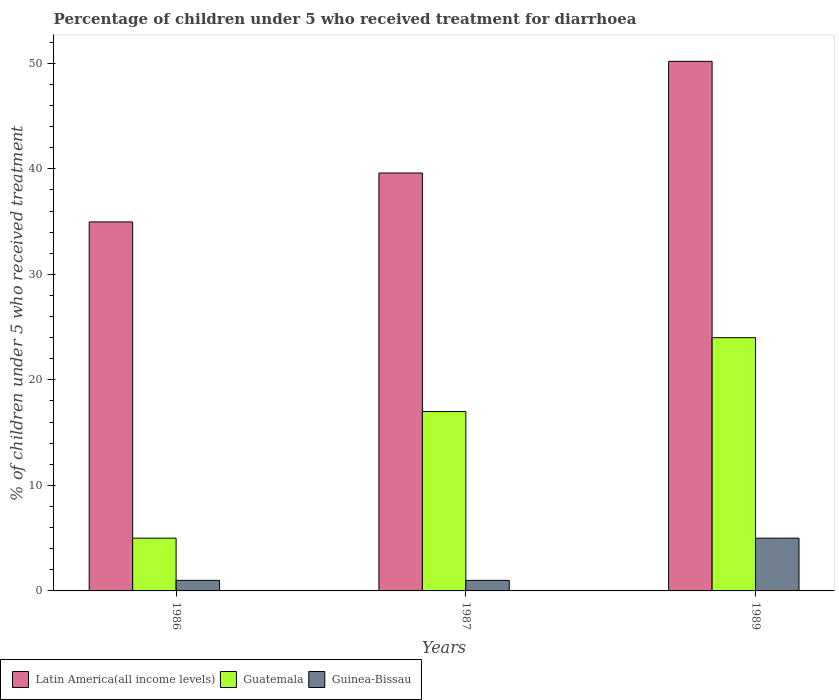How many different coloured bars are there?
Offer a very short reply. 3. Are the number of bars per tick equal to the number of legend labels?
Provide a short and direct response. Yes. Are the number of bars on each tick of the X-axis equal?
Your response must be concise. Yes. How many bars are there on the 1st tick from the left?
Ensure brevity in your answer.  3. How many bars are there on the 1st tick from the right?
Keep it short and to the point. 3. In how many cases, is the number of bars for a given year not equal to the number of legend labels?
Keep it short and to the point. 0. What is the percentage of children who received treatment for diarrhoea  in Latin America(all income levels) in 1987?
Keep it short and to the point. 39.6. Across all years, what is the maximum percentage of children who received treatment for diarrhoea  in Latin America(all income levels)?
Your answer should be very brief. 50.19. Across all years, what is the minimum percentage of children who received treatment for diarrhoea  in Latin America(all income levels)?
Your answer should be compact. 34.97. What is the total percentage of children who received treatment for diarrhoea  in Latin America(all income levels) in the graph?
Ensure brevity in your answer.  124.76. What is the difference between the percentage of children who received treatment for diarrhoea  in Latin America(all income levels) in 1986 and that in 1987?
Provide a short and direct response. -4.64. What is the difference between the percentage of children who received treatment for diarrhoea  in Latin America(all income levels) in 1986 and the percentage of children who received treatment for diarrhoea  in Guatemala in 1987?
Keep it short and to the point. 17.97. What is the average percentage of children who received treatment for diarrhoea  in Guinea-Bissau per year?
Your answer should be compact. 2.33. What is the ratio of the percentage of children who received treatment for diarrhoea  in Latin America(all income levels) in 1986 to that in 1989?
Make the answer very short. 0.7. What is the difference between the highest and the second highest percentage of children who received treatment for diarrhoea  in Guinea-Bissau?
Keep it short and to the point. 4. What is the difference between the highest and the lowest percentage of children who received treatment for diarrhoea  in Latin America(all income levels)?
Provide a succinct answer. 15.22. In how many years, is the percentage of children who received treatment for diarrhoea  in Latin America(all income levels) greater than the average percentage of children who received treatment for diarrhoea  in Latin America(all income levels) taken over all years?
Ensure brevity in your answer.  1. What does the 3rd bar from the left in 1989 represents?
Offer a very short reply. Guinea-Bissau. What does the 1st bar from the right in 1987 represents?
Give a very brief answer. Guinea-Bissau. Is it the case that in every year, the sum of the percentage of children who received treatment for diarrhoea  in Guatemala and percentage of children who received treatment for diarrhoea  in Latin America(all income levels) is greater than the percentage of children who received treatment for diarrhoea  in Guinea-Bissau?
Your answer should be very brief. Yes. How many bars are there?
Ensure brevity in your answer.  9. How many years are there in the graph?
Your answer should be very brief. 3. What is the difference between two consecutive major ticks on the Y-axis?
Offer a very short reply. 10. How many legend labels are there?
Make the answer very short. 3. What is the title of the graph?
Ensure brevity in your answer.  Percentage of children under 5 who received treatment for diarrhoea. Does "Sao Tome and Principe" appear as one of the legend labels in the graph?
Provide a succinct answer. No. What is the label or title of the X-axis?
Offer a terse response. Years. What is the label or title of the Y-axis?
Your answer should be compact. % of children under 5 who received treatment. What is the % of children under 5 who received treatment in Latin America(all income levels) in 1986?
Give a very brief answer. 34.97. What is the % of children under 5 who received treatment in Latin America(all income levels) in 1987?
Provide a short and direct response. 39.6. What is the % of children under 5 who received treatment in Guatemala in 1987?
Provide a succinct answer. 17. What is the % of children under 5 who received treatment in Latin America(all income levels) in 1989?
Provide a succinct answer. 50.19. Across all years, what is the maximum % of children under 5 who received treatment of Latin America(all income levels)?
Offer a terse response. 50.19. Across all years, what is the minimum % of children under 5 who received treatment of Latin America(all income levels)?
Offer a very short reply. 34.97. Across all years, what is the minimum % of children under 5 who received treatment in Guatemala?
Your answer should be very brief. 5. Across all years, what is the minimum % of children under 5 who received treatment of Guinea-Bissau?
Make the answer very short. 1. What is the total % of children under 5 who received treatment in Latin America(all income levels) in the graph?
Give a very brief answer. 124.76. What is the total % of children under 5 who received treatment of Guinea-Bissau in the graph?
Provide a short and direct response. 7. What is the difference between the % of children under 5 who received treatment of Latin America(all income levels) in 1986 and that in 1987?
Provide a succinct answer. -4.64. What is the difference between the % of children under 5 who received treatment of Guatemala in 1986 and that in 1987?
Make the answer very short. -12. What is the difference between the % of children under 5 who received treatment in Guinea-Bissau in 1986 and that in 1987?
Your answer should be compact. 0. What is the difference between the % of children under 5 who received treatment of Latin America(all income levels) in 1986 and that in 1989?
Offer a terse response. -15.22. What is the difference between the % of children under 5 who received treatment in Guinea-Bissau in 1986 and that in 1989?
Offer a very short reply. -4. What is the difference between the % of children under 5 who received treatment in Latin America(all income levels) in 1987 and that in 1989?
Provide a succinct answer. -10.58. What is the difference between the % of children under 5 who received treatment in Guinea-Bissau in 1987 and that in 1989?
Ensure brevity in your answer.  -4. What is the difference between the % of children under 5 who received treatment in Latin America(all income levels) in 1986 and the % of children under 5 who received treatment in Guatemala in 1987?
Provide a succinct answer. 17.97. What is the difference between the % of children under 5 who received treatment in Latin America(all income levels) in 1986 and the % of children under 5 who received treatment in Guinea-Bissau in 1987?
Offer a very short reply. 33.97. What is the difference between the % of children under 5 who received treatment of Latin America(all income levels) in 1986 and the % of children under 5 who received treatment of Guatemala in 1989?
Your answer should be compact. 10.97. What is the difference between the % of children under 5 who received treatment in Latin America(all income levels) in 1986 and the % of children under 5 who received treatment in Guinea-Bissau in 1989?
Offer a very short reply. 29.97. What is the difference between the % of children under 5 who received treatment in Guatemala in 1986 and the % of children under 5 who received treatment in Guinea-Bissau in 1989?
Provide a succinct answer. 0. What is the difference between the % of children under 5 who received treatment of Latin America(all income levels) in 1987 and the % of children under 5 who received treatment of Guatemala in 1989?
Your response must be concise. 15.6. What is the difference between the % of children under 5 who received treatment of Latin America(all income levels) in 1987 and the % of children under 5 who received treatment of Guinea-Bissau in 1989?
Offer a very short reply. 34.6. What is the average % of children under 5 who received treatment of Latin America(all income levels) per year?
Provide a succinct answer. 41.59. What is the average % of children under 5 who received treatment in Guatemala per year?
Your answer should be compact. 15.33. What is the average % of children under 5 who received treatment in Guinea-Bissau per year?
Make the answer very short. 2.33. In the year 1986, what is the difference between the % of children under 5 who received treatment in Latin America(all income levels) and % of children under 5 who received treatment in Guatemala?
Ensure brevity in your answer.  29.97. In the year 1986, what is the difference between the % of children under 5 who received treatment of Latin America(all income levels) and % of children under 5 who received treatment of Guinea-Bissau?
Keep it short and to the point. 33.97. In the year 1986, what is the difference between the % of children under 5 who received treatment in Guatemala and % of children under 5 who received treatment in Guinea-Bissau?
Your answer should be very brief. 4. In the year 1987, what is the difference between the % of children under 5 who received treatment in Latin America(all income levels) and % of children under 5 who received treatment in Guatemala?
Your response must be concise. 22.6. In the year 1987, what is the difference between the % of children under 5 who received treatment of Latin America(all income levels) and % of children under 5 who received treatment of Guinea-Bissau?
Your answer should be compact. 38.6. In the year 1989, what is the difference between the % of children under 5 who received treatment of Latin America(all income levels) and % of children under 5 who received treatment of Guatemala?
Offer a terse response. 26.19. In the year 1989, what is the difference between the % of children under 5 who received treatment in Latin America(all income levels) and % of children under 5 who received treatment in Guinea-Bissau?
Give a very brief answer. 45.19. What is the ratio of the % of children under 5 who received treatment of Latin America(all income levels) in 1986 to that in 1987?
Your answer should be very brief. 0.88. What is the ratio of the % of children under 5 who received treatment of Guatemala in 1986 to that in 1987?
Your answer should be compact. 0.29. What is the ratio of the % of children under 5 who received treatment in Guinea-Bissau in 1986 to that in 1987?
Your answer should be compact. 1. What is the ratio of the % of children under 5 who received treatment of Latin America(all income levels) in 1986 to that in 1989?
Offer a terse response. 0.7. What is the ratio of the % of children under 5 who received treatment in Guatemala in 1986 to that in 1989?
Ensure brevity in your answer.  0.21. What is the ratio of the % of children under 5 who received treatment in Latin America(all income levels) in 1987 to that in 1989?
Ensure brevity in your answer.  0.79. What is the ratio of the % of children under 5 who received treatment in Guatemala in 1987 to that in 1989?
Make the answer very short. 0.71. What is the difference between the highest and the second highest % of children under 5 who received treatment of Latin America(all income levels)?
Your response must be concise. 10.58. What is the difference between the highest and the second highest % of children under 5 who received treatment in Guinea-Bissau?
Provide a short and direct response. 4. What is the difference between the highest and the lowest % of children under 5 who received treatment in Latin America(all income levels)?
Keep it short and to the point. 15.22. What is the difference between the highest and the lowest % of children under 5 who received treatment in Guatemala?
Your answer should be very brief. 19. What is the difference between the highest and the lowest % of children under 5 who received treatment in Guinea-Bissau?
Provide a succinct answer. 4. 